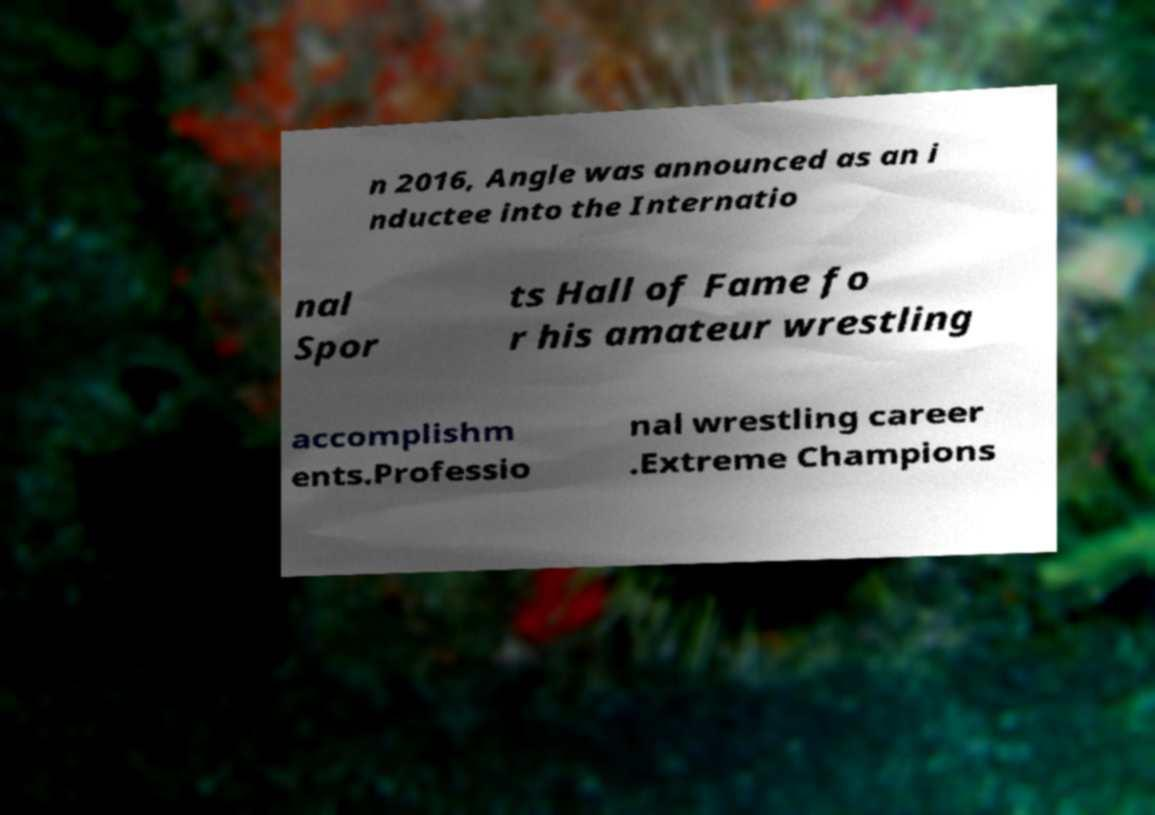I need the written content from this picture converted into text. Can you do that? n 2016, Angle was announced as an i nductee into the Internatio nal Spor ts Hall of Fame fo r his amateur wrestling accomplishm ents.Professio nal wrestling career .Extreme Champions 